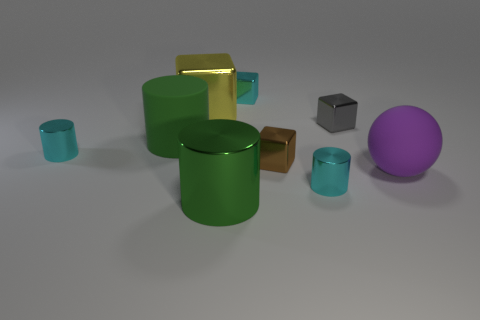Subtract all green blocks. How many green cylinders are left? 2 Subtract all brown cubes. How many cubes are left? 3 Subtract all tiny blocks. How many blocks are left? 1 Subtract 1 cubes. How many cubes are left? 3 Subtract all gray cylinders. Subtract all brown blocks. How many cylinders are left? 4 Subtract all spheres. How many objects are left? 8 Subtract 1 cyan blocks. How many objects are left? 8 Subtract all big spheres. Subtract all green rubber cylinders. How many objects are left? 7 Add 6 tiny cyan cylinders. How many tiny cyan cylinders are left? 8 Add 3 big red shiny cubes. How many big red shiny cubes exist? 3 